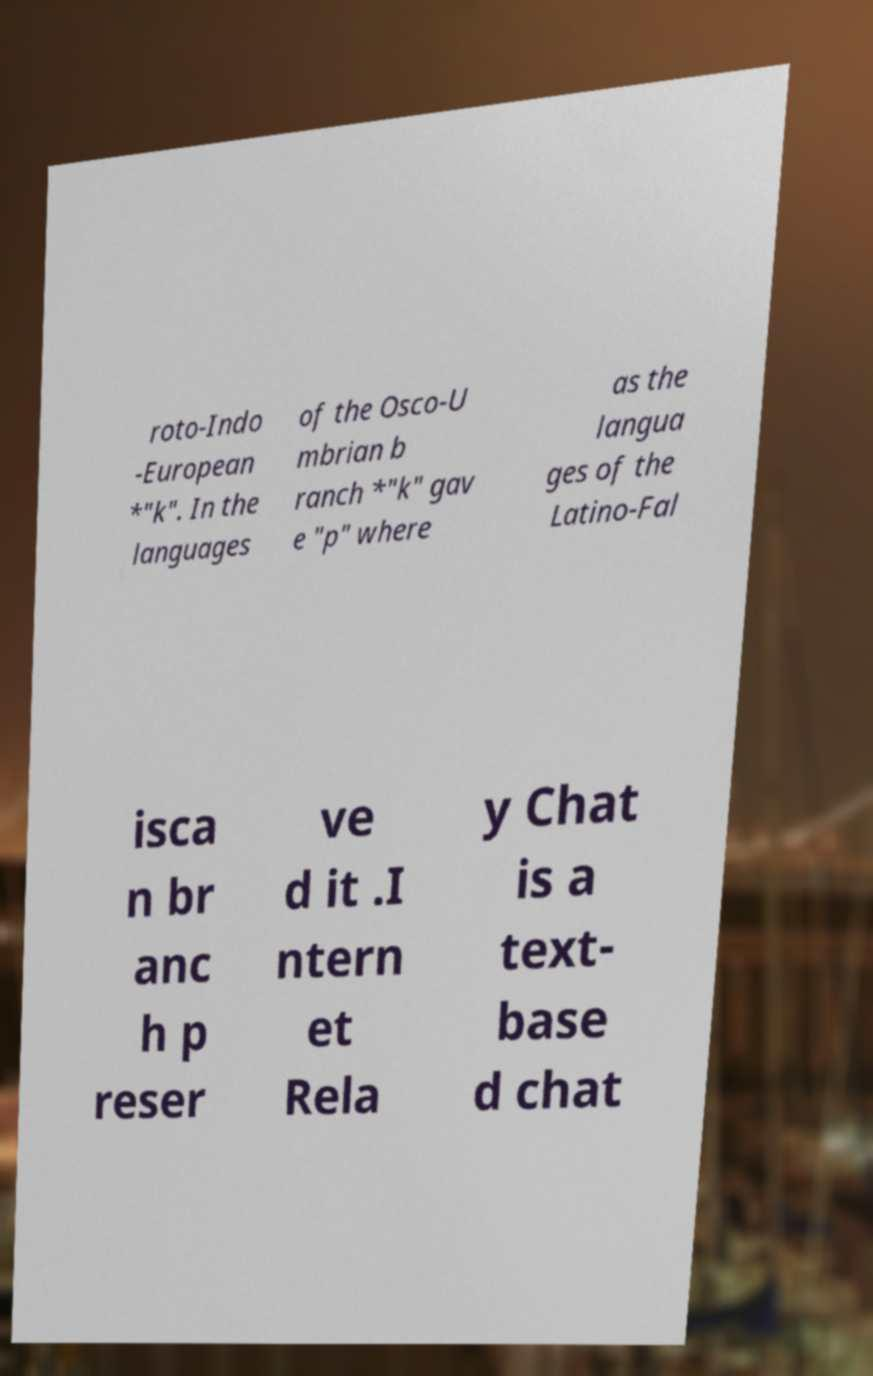Please identify and transcribe the text found in this image. roto-Indo -European *"k". In the languages of the Osco-U mbrian b ranch *"k" gav e "p" where as the langua ges of the Latino-Fal isca n br anc h p reser ve d it .I ntern et Rela y Chat is a text- base d chat 